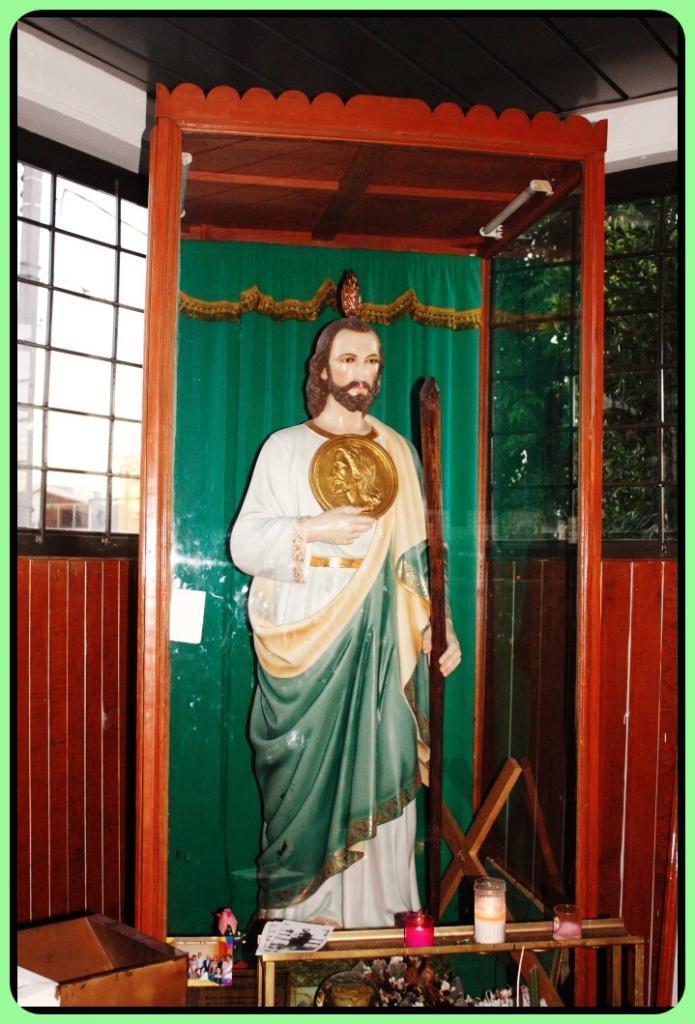How would you summarize this image in a sentence or two? This image is taken indoors. At the top of the image there is a ceiling. In the background there is a wall with windows. Through the windows we can see there are a few trees. In the middle of the image there is a statue of a god in the glass box. At the bottom of the image there is a table with a box and a few candles on it. 